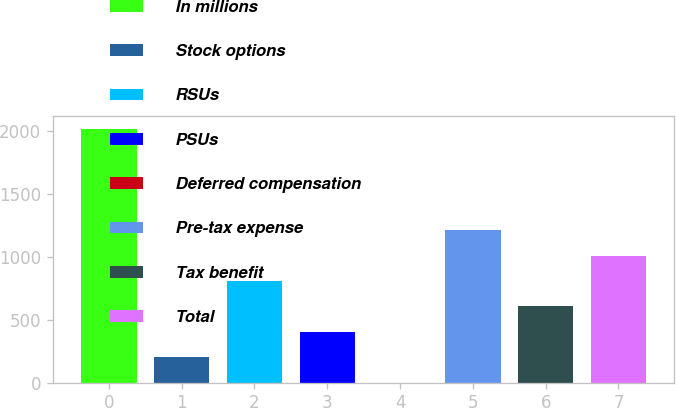Convert chart. <chart><loc_0><loc_0><loc_500><loc_500><bar_chart><fcel>In millions<fcel>Stock options<fcel>RSUs<fcel>PSUs<fcel>Deferred compensation<fcel>Pre-tax expense<fcel>Tax benefit<fcel>Total<nl><fcel>2016<fcel>202.32<fcel>806.88<fcel>403.84<fcel>0.8<fcel>1209.92<fcel>605.36<fcel>1008.4<nl></chart> 